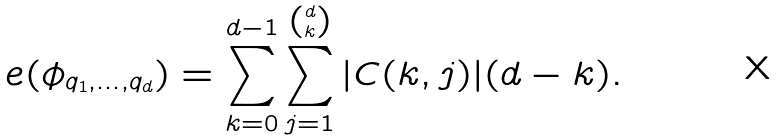<formula> <loc_0><loc_0><loc_500><loc_500>e ( \phi _ { q _ { 1 } , \dots , q _ { d } } ) = \sum _ { k = 0 } ^ { d - 1 } { \sum _ { j = 1 } ^ { d \choose k } { | C ( k , j ) | ( d - k ) } } .</formula> 